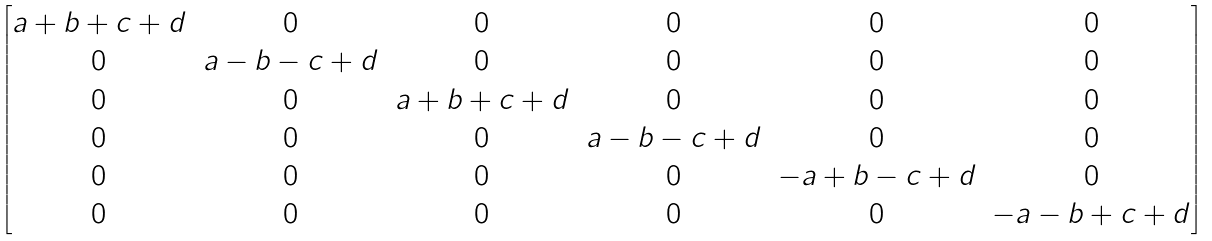Convert formula to latex. <formula><loc_0><loc_0><loc_500><loc_500>\begin{bmatrix} a + b + c + d & 0 & 0 & 0 & 0 & 0 \\ 0 & a - b - c + d & 0 & 0 & 0 & 0 \\ 0 & 0 & a + b + c + d & 0 & 0 & 0 \\ 0 & 0 & 0 & a - b - c + d & 0 & 0 \\ 0 & 0 & 0 & 0 & - a + b - c + d & 0 \\ 0 & 0 & 0 & 0 & 0 & - a - b + c + d \end{bmatrix}</formula> 